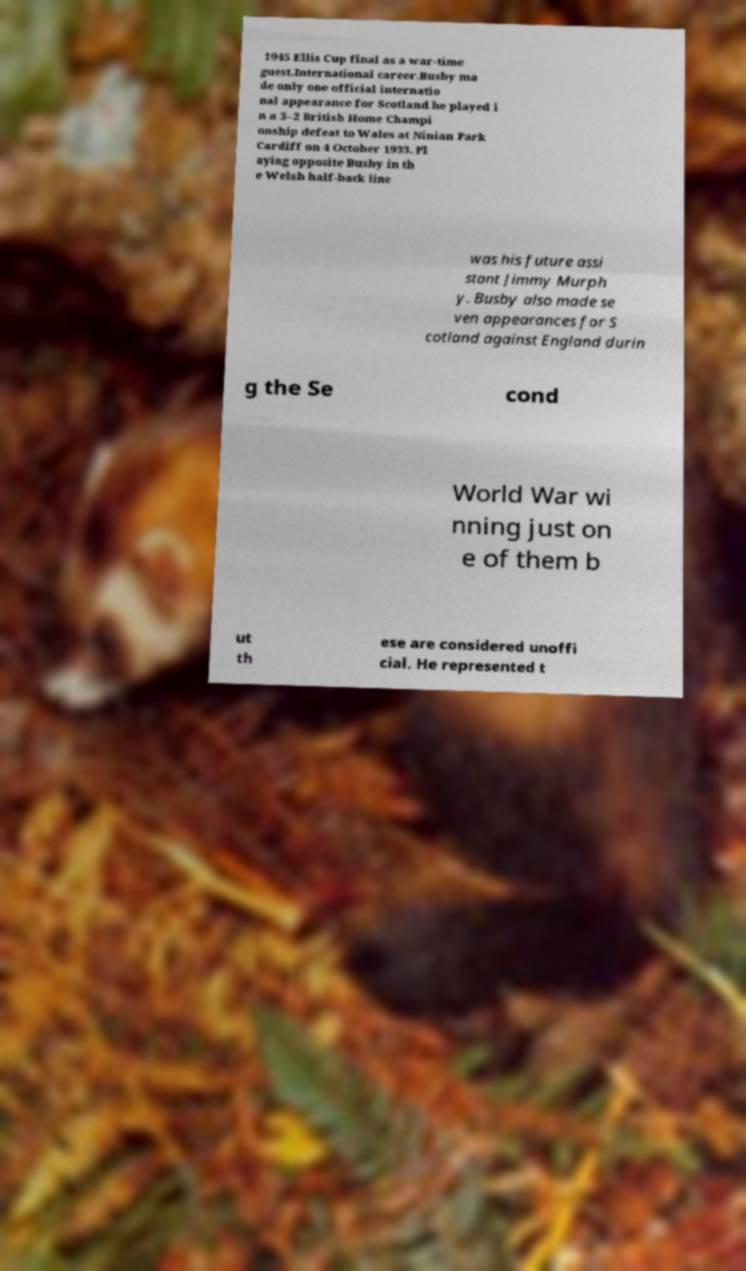Could you extract and type out the text from this image? 1945 Ellis Cup final as a war-time guest.International career.Busby ma de only one official internatio nal appearance for Scotland he played i n a 3–2 British Home Champi onship defeat to Wales at Ninian Park Cardiff on 4 October 1933. Pl aying opposite Busby in th e Welsh half-back line was his future assi stant Jimmy Murph y. Busby also made se ven appearances for S cotland against England durin g the Se cond World War wi nning just on e of them b ut th ese are considered unoffi cial. He represented t 